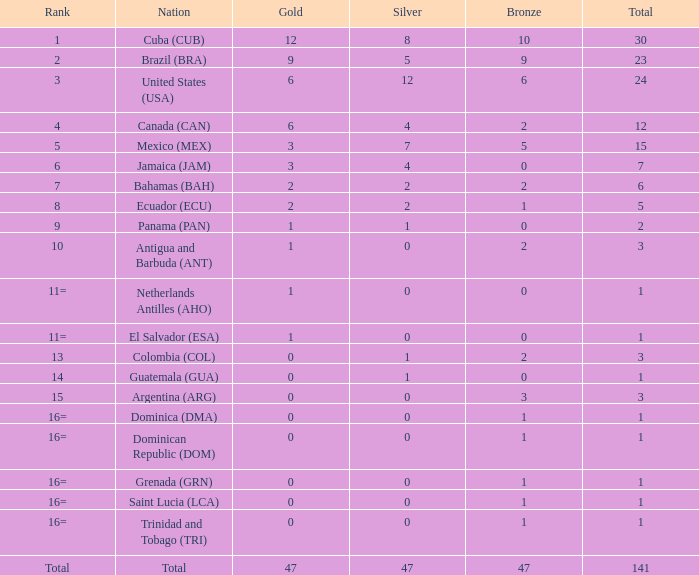What is the sum of gold with a combined value under 1? None. Parse the full table. {'header': ['Rank', 'Nation', 'Gold', 'Silver', 'Bronze', 'Total'], 'rows': [['1', 'Cuba (CUB)', '12', '8', '10', '30'], ['2', 'Brazil (BRA)', '9', '5', '9', '23'], ['3', 'United States (USA)', '6', '12', '6', '24'], ['4', 'Canada (CAN)', '6', '4', '2', '12'], ['5', 'Mexico (MEX)', '3', '7', '5', '15'], ['6', 'Jamaica (JAM)', '3', '4', '0', '7'], ['7', 'Bahamas (BAH)', '2', '2', '2', '6'], ['8', 'Ecuador (ECU)', '2', '2', '1', '5'], ['9', 'Panama (PAN)', '1', '1', '0', '2'], ['10', 'Antigua and Barbuda (ANT)', '1', '0', '2', '3'], ['11=', 'Netherlands Antilles (AHO)', '1', '0', '0', '1'], ['11=', 'El Salvador (ESA)', '1', '0', '0', '1'], ['13', 'Colombia (COL)', '0', '1', '2', '3'], ['14', 'Guatemala (GUA)', '0', '1', '0', '1'], ['15', 'Argentina (ARG)', '0', '0', '3', '3'], ['16=', 'Dominica (DMA)', '0', '0', '1', '1'], ['16=', 'Dominican Republic (DOM)', '0', '0', '1', '1'], ['16=', 'Grenada (GRN)', '0', '0', '1', '1'], ['16=', 'Saint Lucia (LCA)', '0', '0', '1', '1'], ['16=', 'Trinidad and Tobago (TRI)', '0', '0', '1', '1'], ['Total', 'Total', '47', '47', '47', '141']]} 